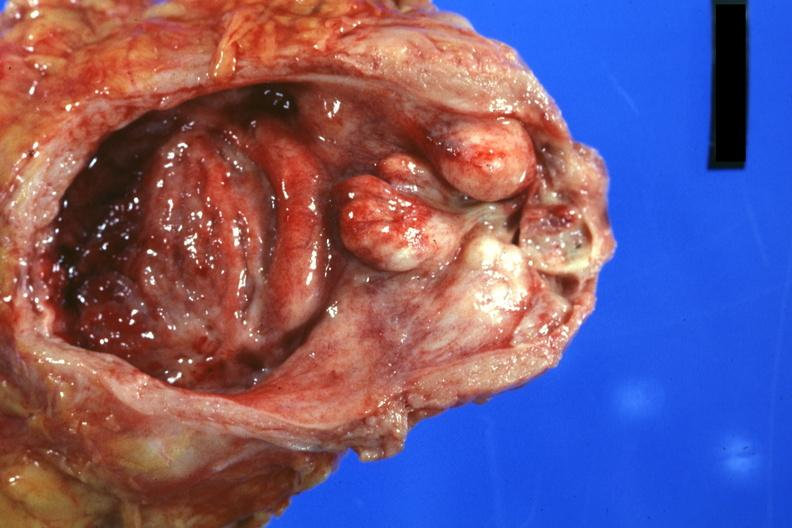what does this image show?
Answer the question using a single word or phrase. Good photo nodular lateral lobes large median lobe and hyperemic bladder mucosa with increased trabeculation 